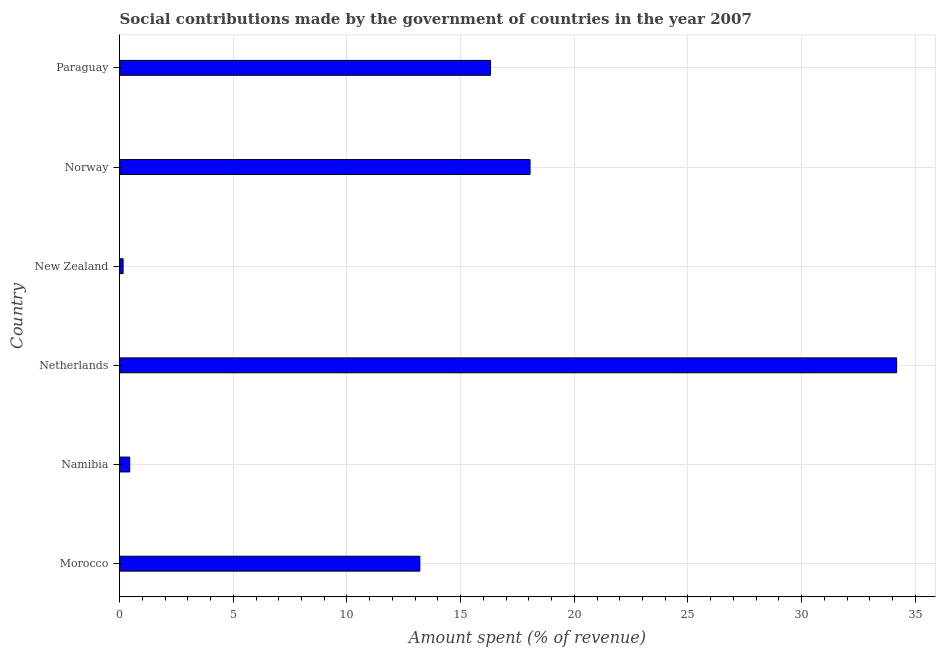What is the title of the graph?
Offer a very short reply. Social contributions made by the government of countries in the year 2007. What is the label or title of the X-axis?
Provide a succinct answer. Amount spent (% of revenue). What is the amount spent in making social contributions in New Zealand?
Your response must be concise. 0.15. Across all countries, what is the maximum amount spent in making social contributions?
Your answer should be very brief. 34.18. Across all countries, what is the minimum amount spent in making social contributions?
Provide a succinct answer. 0.15. In which country was the amount spent in making social contributions maximum?
Give a very brief answer. Netherlands. In which country was the amount spent in making social contributions minimum?
Offer a terse response. New Zealand. What is the sum of the amount spent in making social contributions?
Offer a terse response. 82.35. What is the difference between the amount spent in making social contributions in Morocco and Netherlands?
Provide a succinct answer. -20.97. What is the average amount spent in making social contributions per country?
Ensure brevity in your answer.  13.72. What is the median amount spent in making social contributions?
Your answer should be very brief. 14.76. In how many countries, is the amount spent in making social contributions greater than 15 %?
Ensure brevity in your answer.  3. What is the ratio of the amount spent in making social contributions in Netherlands to that in Norway?
Your answer should be very brief. 1.89. Is the amount spent in making social contributions in New Zealand less than that in Paraguay?
Your response must be concise. Yes. Is the difference between the amount spent in making social contributions in Namibia and New Zealand greater than the difference between any two countries?
Your answer should be compact. No. What is the difference between the highest and the second highest amount spent in making social contributions?
Offer a very short reply. 16.12. Is the sum of the amount spent in making social contributions in Morocco and Norway greater than the maximum amount spent in making social contributions across all countries?
Give a very brief answer. No. What is the difference between the highest and the lowest amount spent in making social contributions?
Ensure brevity in your answer.  34.02. How many countries are there in the graph?
Ensure brevity in your answer.  6. What is the difference between two consecutive major ticks on the X-axis?
Your answer should be very brief. 5. Are the values on the major ticks of X-axis written in scientific E-notation?
Offer a very short reply. No. What is the Amount spent (% of revenue) of Morocco?
Keep it short and to the point. 13.21. What is the Amount spent (% of revenue) of Namibia?
Provide a succinct answer. 0.44. What is the Amount spent (% of revenue) of Netherlands?
Your answer should be very brief. 34.18. What is the Amount spent (% of revenue) in New Zealand?
Make the answer very short. 0.15. What is the Amount spent (% of revenue) in Norway?
Offer a very short reply. 18.05. What is the Amount spent (% of revenue) of Paraguay?
Provide a short and direct response. 16.32. What is the difference between the Amount spent (% of revenue) in Morocco and Namibia?
Offer a terse response. 12.76. What is the difference between the Amount spent (% of revenue) in Morocco and Netherlands?
Provide a short and direct response. -20.97. What is the difference between the Amount spent (% of revenue) in Morocco and New Zealand?
Offer a terse response. 13.05. What is the difference between the Amount spent (% of revenue) in Morocco and Norway?
Keep it short and to the point. -4.85. What is the difference between the Amount spent (% of revenue) in Morocco and Paraguay?
Make the answer very short. -3.11. What is the difference between the Amount spent (% of revenue) in Namibia and Netherlands?
Your answer should be compact. -33.73. What is the difference between the Amount spent (% of revenue) in Namibia and New Zealand?
Your answer should be compact. 0.29. What is the difference between the Amount spent (% of revenue) in Namibia and Norway?
Ensure brevity in your answer.  -17.61. What is the difference between the Amount spent (% of revenue) in Namibia and Paraguay?
Provide a succinct answer. -15.87. What is the difference between the Amount spent (% of revenue) in Netherlands and New Zealand?
Your response must be concise. 34.02. What is the difference between the Amount spent (% of revenue) in Netherlands and Norway?
Give a very brief answer. 16.12. What is the difference between the Amount spent (% of revenue) in Netherlands and Paraguay?
Give a very brief answer. 17.86. What is the difference between the Amount spent (% of revenue) in New Zealand and Norway?
Make the answer very short. -17.9. What is the difference between the Amount spent (% of revenue) in New Zealand and Paraguay?
Your response must be concise. -16.16. What is the difference between the Amount spent (% of revenue) in Norway and Paraguay?
Give a very brief answer. 1.74. What is the ratio of the Amount spent (% of revenue) in Morocco to that in Namibia?
Your response must be concise. 29.78. What is the ratio of the Amount spent (% of revenue) in Morocco to that in Netherlands?
Give a very brief answer. 0.39. What is the ratio of the Amount spent (% of revenue) in Morocco to that in New Zealand?
Your answer should be very brief. 86.11. What is the ratio of the Amount spent (% of revenue) in Morocco to that in Norway?
Keep it short and to the point. 0.73. What is the ratio of the Amount spent (% of revenue) in Morocco to that in Paraguay?
Provide a short and direct response. 0.81. What is the ratio of the Amount spent (% of revenue) in Namibia to that in Netherlands?
Ensure brevity in your answer.  0.01. What is the ratio of the Amount spent (% of revenue) in Namibia to that in New Zealand?
Keep it short and to the point. 2.89. What is the ratio of the Amount spent (% of revenue) in Namibia to that in Norway?
Offer a very short reply. 0.03. What is the ratio of the Amount spent (% of revenue) in Namibia to that in Paraguay?
Offer a very short reply. 0.03. What is the ratio of the Amount spent (% of revenue) in Netherlands to that in New Zealand?
Give a very brief answer. 222.86. What is the ratio of the Amount spent (% of revenue) in Netherlands to that in Norway?
Your answer should be very brief. 1.89. What is the ratio of the Amount spent (% of revenue) in Netherlands to that in Paraguay?
Keep it short and to the point. 2.1. What is the ratio of the Amount spent (% of revenue) in New Zealand to that in Norway?
Provide a short and direct response. 0.01. What is the ratio of the Amount spent (% of revenue) in New Zealand to that in Paraguay?
Your answer should be compact. 0.01. What is the ratio of the Amount spent (% of revenue) in Norway to that in Paraguay?
Give a very brief answer. 1.11. 